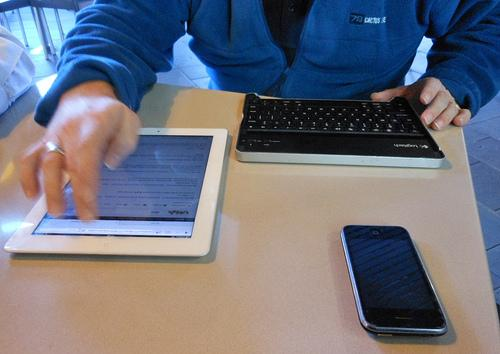State what the main subject is focusing on and their current activity. A person donning a blue garment is busy tapping on an iPad displayed on a table. Mention the primary object in the image along with its major activity. A person in a blue jacket is touching an iPad on a wooden table. Mention the key subject in the image and the action they perform. A person wearing a blue sweater is interacting with a white iPad on a table. In one sentence, describe the central subject and their engagement within the image. A person clad in a blue jacket is navigating an iPad, surrounded by tech gadgets on a wooden table. What is the main activity taking place in the picture? A person is using a tablet on a table with other technology items. Compose a brief statement describing the principal subject and their interaction within the photograph. A blue-clad individual is engaging with an iPad, accompanied by a cellphone and a keyboard on a table. Briefly describe the scene captured in the image. A person wearing a blue jacket and a ring is interacting with an iPad, with a cellphone and keyboard nearby on a table. Write a simple description that captures the main event occurring in the photo. A person in blue is touching an iPad on a table with a phone and keyboard. Describe the main focus of the image along with their interaction with other objects. A person in a blue jacket is using an iPad, while a cellphone and keyboard are placed on the table. Point out the primary subject and their action in a passive voice. An iPad on a wooden table is being touched by a person in a blue jacket. 